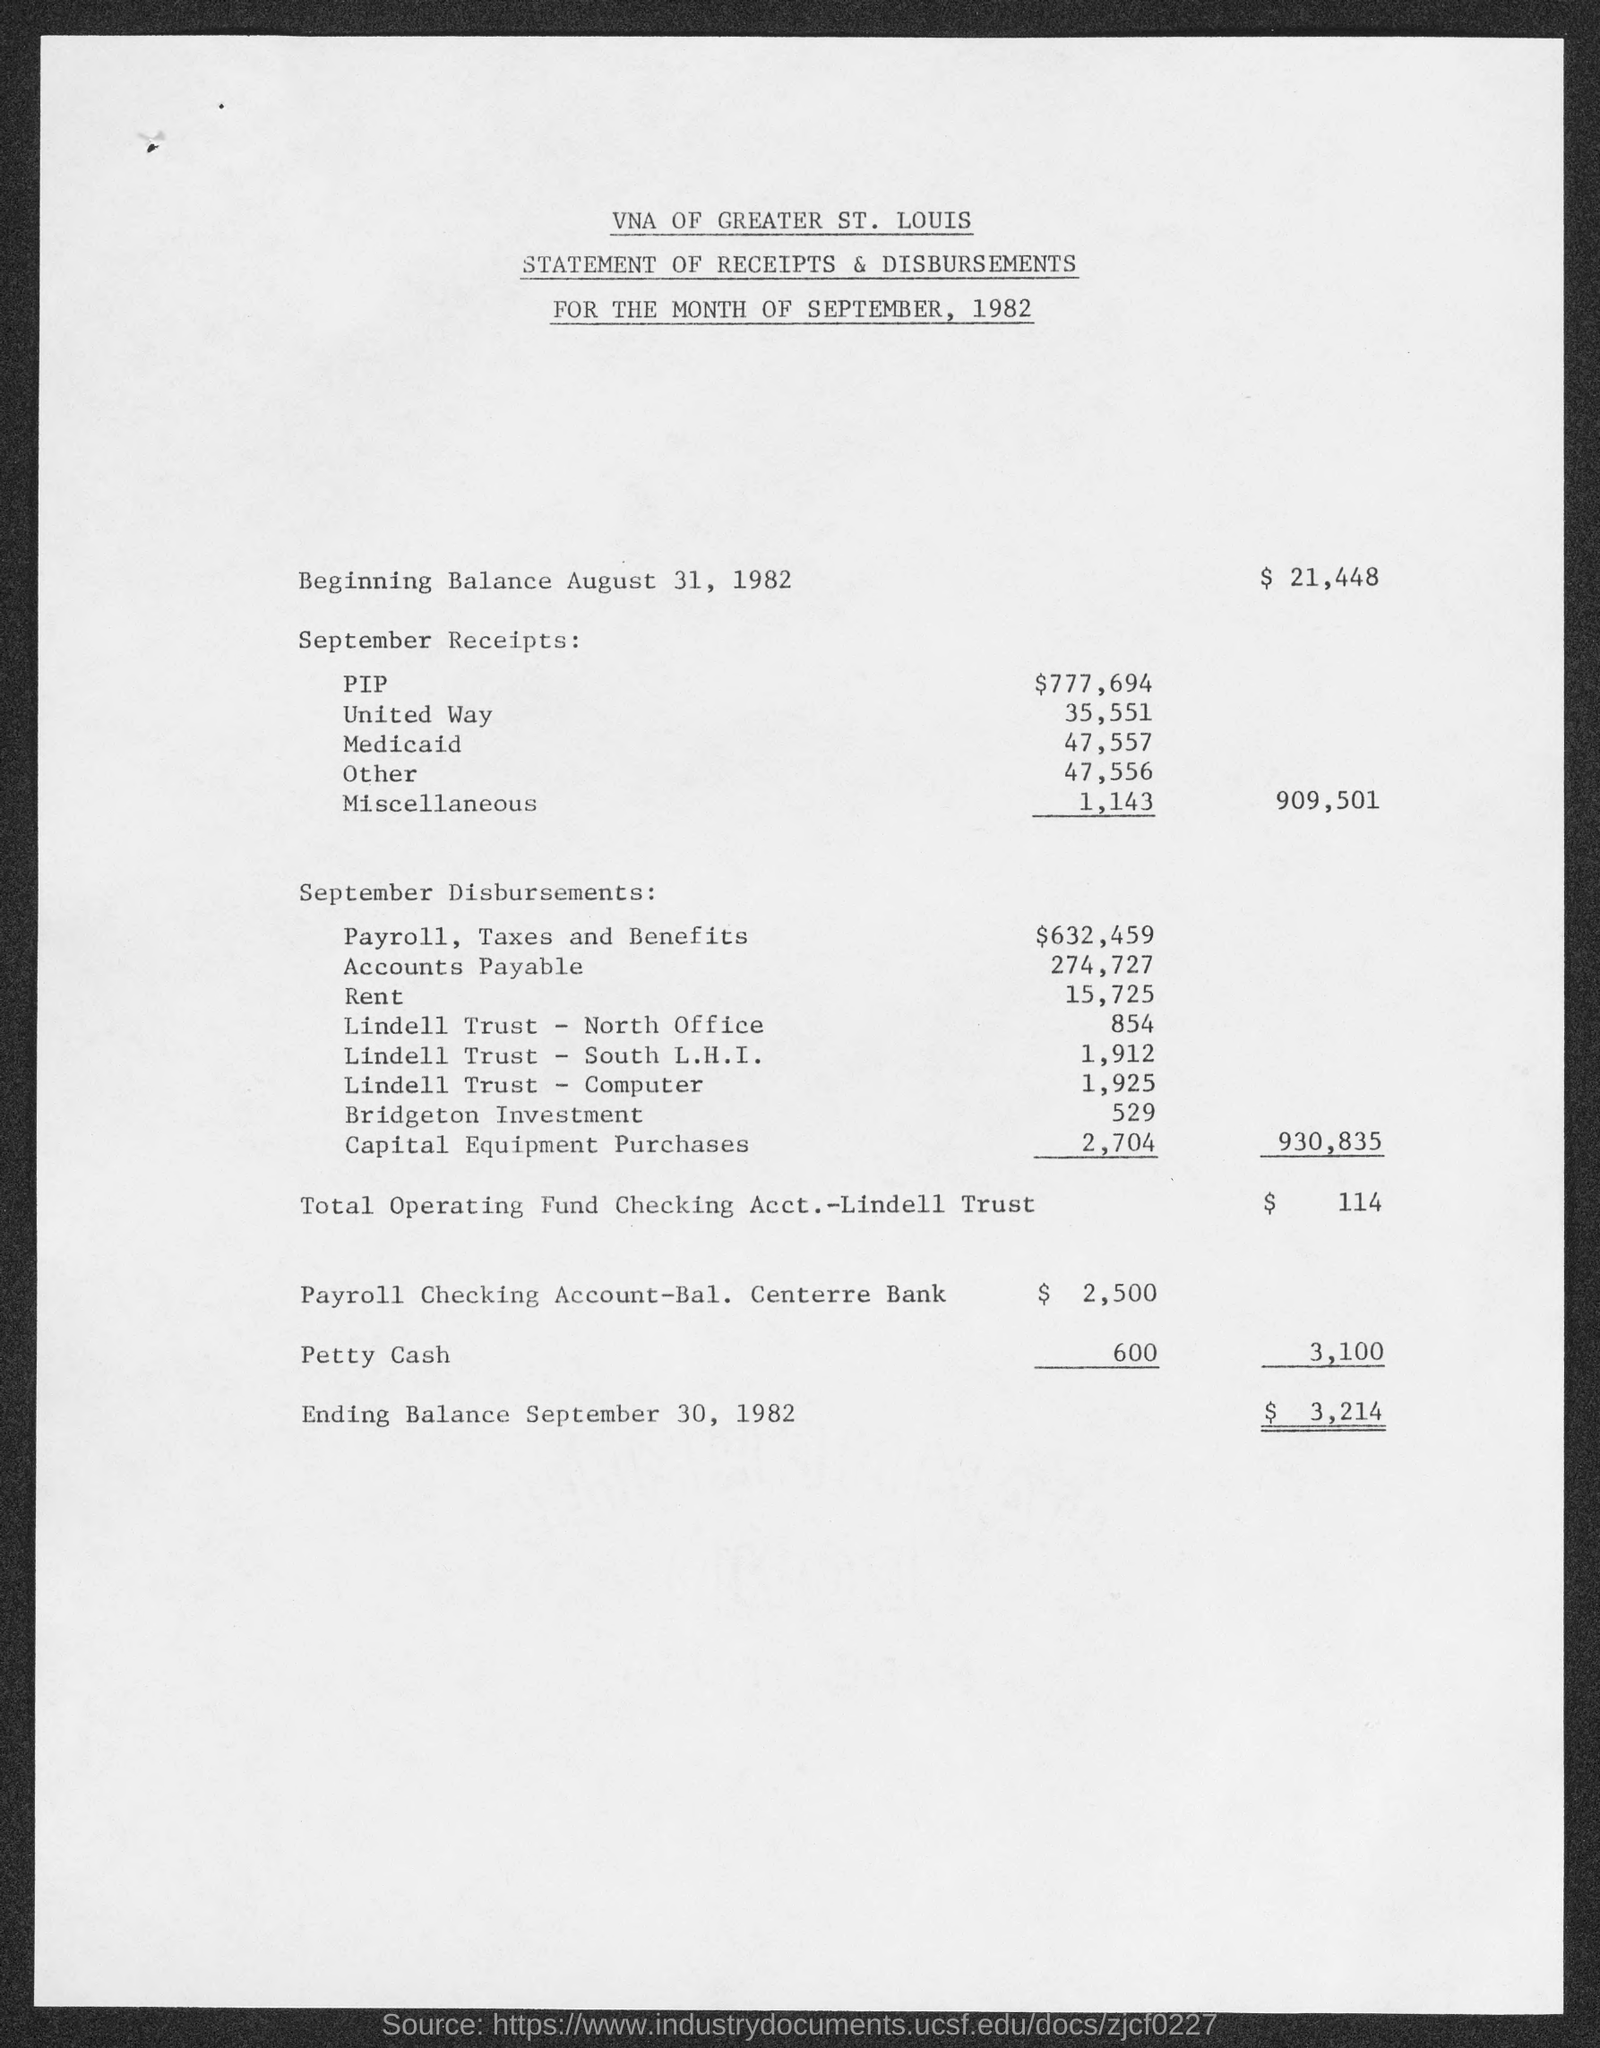What is the first title in the document?
Offer a very short reply. VNA of Greater St. Louis. What is the rent?
Offer a very short reply. 15,725. What is the balance in the end?
Your answer should be compact. $ 3,214. What is the balance in the beginning?
Offer a terse response. $  21,448. 